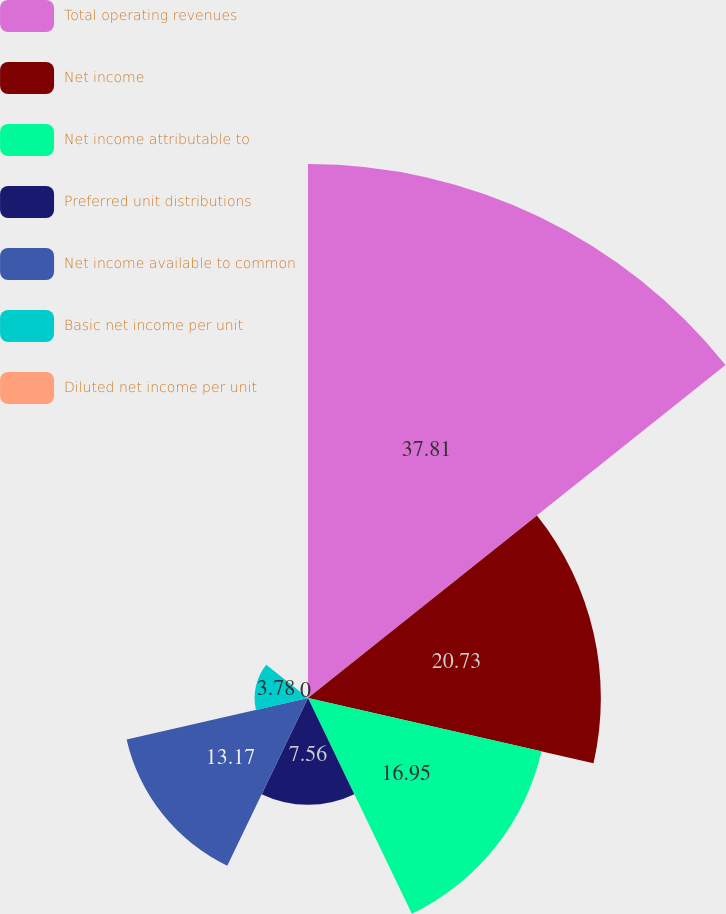Convert chart to OTSL. <chart><loc_0><loc_0><loc_500><loc_500><pie_chart><fcel>Total operating revenues<fcel>Net income<fcel>Net income attributable to<fcel>Preferred unit distributions<fcel>Net income available to common<fcel>Basic net income per unit<fcel>Diluted net income per unit<nl><fcel>37.8%<fcel>20.73%<fcel>16.95%<fcel>7.56%<fcel>13.17%<fcel>3.78%<fcel>0.0%<nl></chart> 